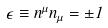Convert formula to latex. <formula><loc_0><loc_0><loc_500><loc_500>\epsilon \equiv n ^ { \mu } n _ { \mu } = \pm 1</formula> 